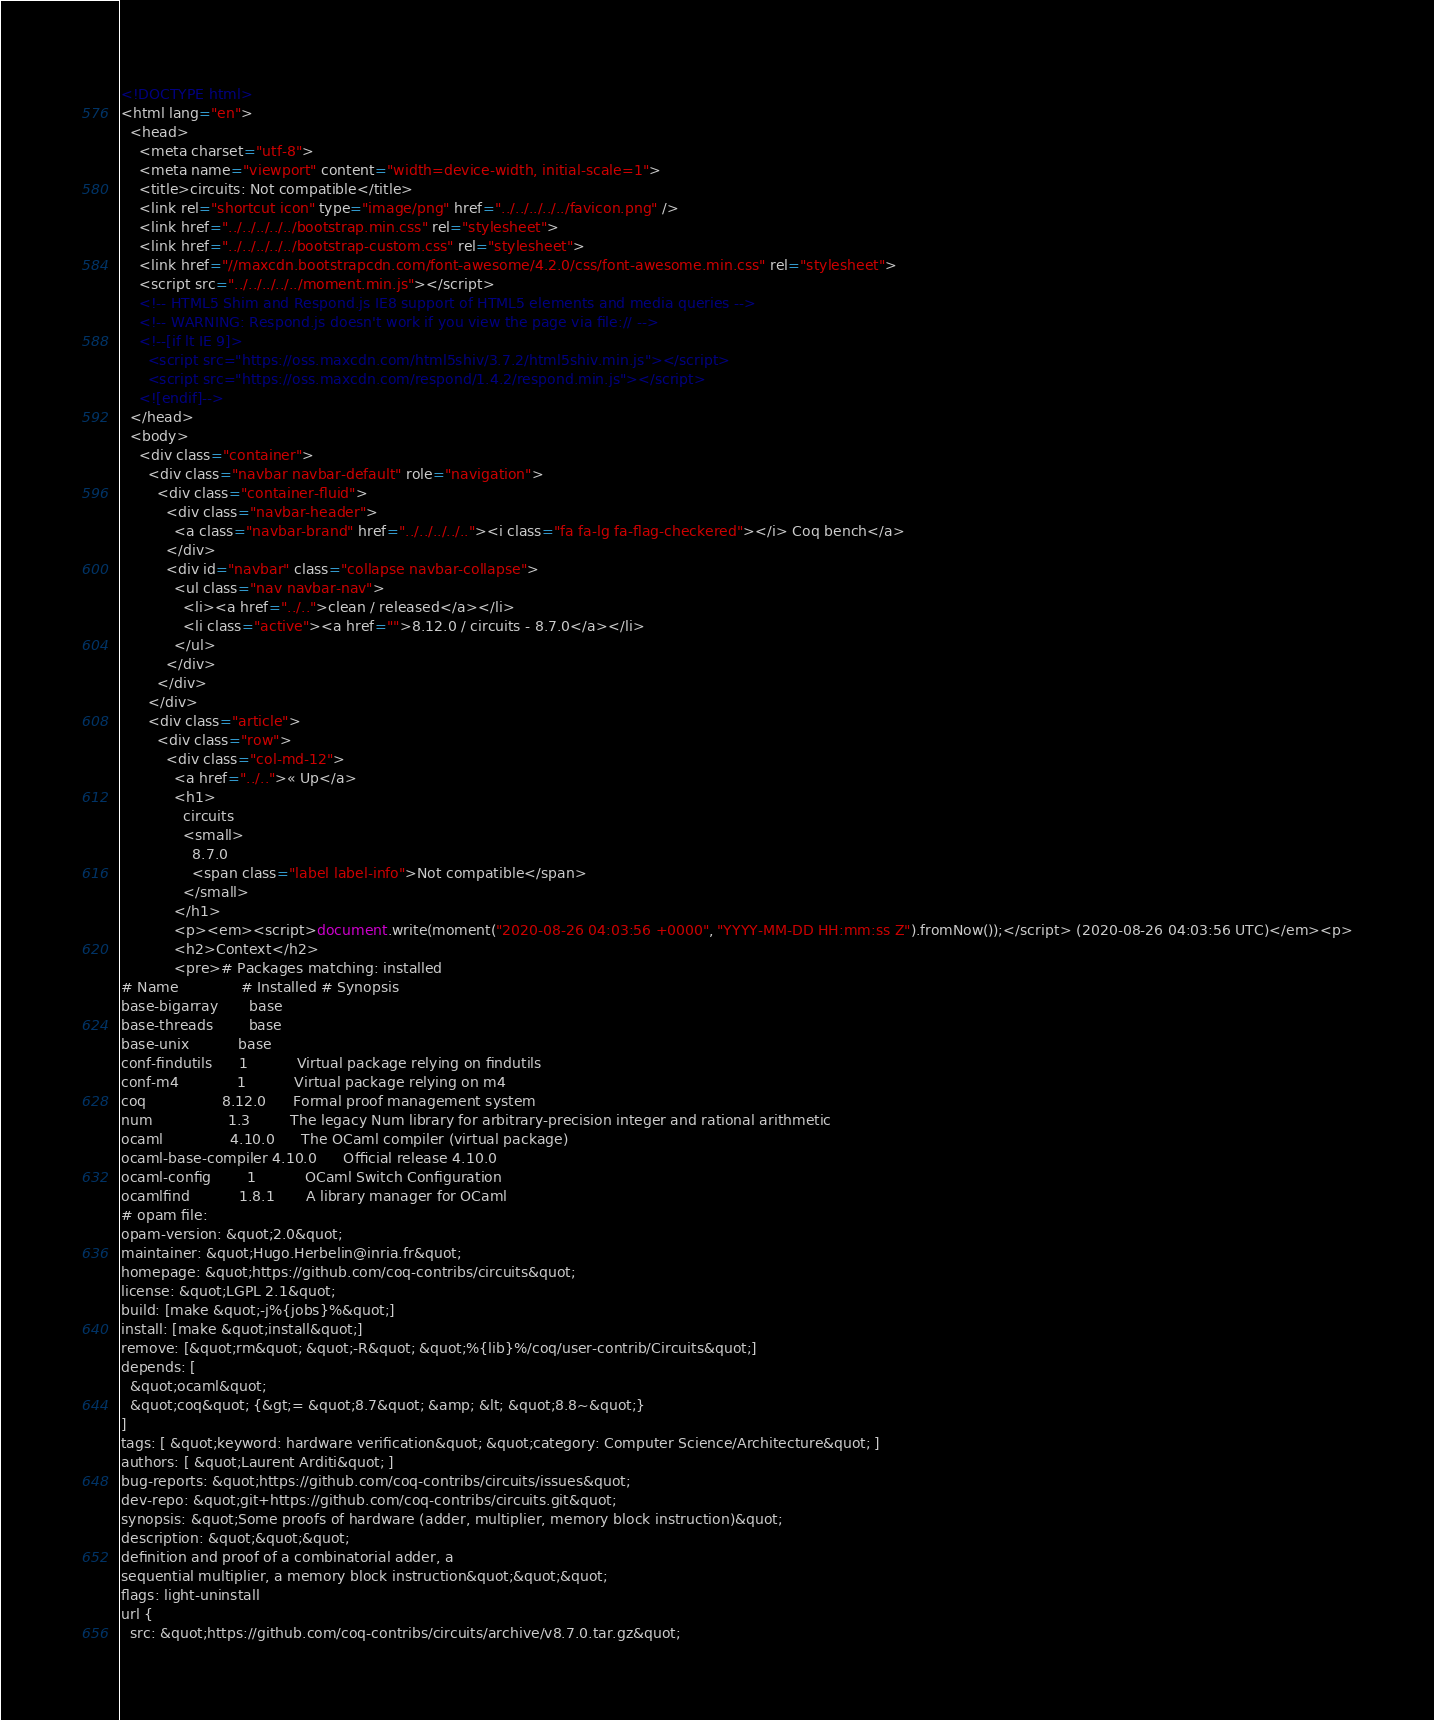Convert code to text. <code><loc_0><loc_0><loc_500><loc_500><_HTML_><!DOCTYPE html>
<html lang="en">
  <head>
    <meta charset="utf-8">
    <meta name="viewport" content="width=device-width, initial-scale=1">
    <title>circuits: Not compatible</title>
    <link rel="shortcut icon" type="image/png" href="../../../../../favicon.png" />
    <link href="../../../../../bootstrap.min.css" rel="stylesheet">
    <link href="../../../../../bootstrap-custom.css" rel="stylesheet">
    <link href="//maxcdn.bootstrapcdn.com/font-awesome/4.2.0/css/font-awesome.min.css" rel="stylesheet">
    <script src="../../../../../moment.min.js"></script>
    <!-- HTML5 Shim and Respond.js IE8 support of HTML5 elements and media queries -->
    <!-- WARNING: Respond.js doesn't work if you view the page via file:// -->
    <!--[if lt IE 9]>
      <script src="https://oss.maxcdn.com/html5shiv/3.7.2/html5shiv.min.js"></script>
      <script src="https://oss.maxcdn.com/respond/1.4.2/respond.min.js"></script>
    <![endif]-->
  </head>
  <body>
    <div class="container">
      <div class="navbar navbar-default" role="navigation">
        <div class="container-fluid">
          <div class="navbar-header">
            <a class="navbar-brand" href="../../../../.."><i class="fa fa-lg fa-flag-checkered"></i> Coq bench</a>
          </div>
          <div id="navbar" class="collapse navbar-collapse">
            <ul class="nav navbar-nav">
              <li><a href="../..">clean / released</a></li>
              <li class="active"><a href="">8.12.0 / circuits - 8.7.0</a></li>
            </ul>
          </div>
        </div>
      </div>
      <div class="article">
        <div class="row">
          <div class="col-md-12">
            <a href="../..">« Up</a>
            <h1>
              circuits
              <small>
                8.7.0
                <span class="label label-info">Not compatible</span>
              </small>
            </h1>
            <p><em><script>document.write(moment("2020-08-26 04:03:56 +0000", "YYYY-MM-DD HH:mm:ss Z").fromNow());</script> (2020-08-26 04:03:56 UTC)</em><p>
            <h2>Context</h2>
            <pre># Packages matching: installed
# Name              # Installed # Synopsis
base-bigarray       base
base-threads        base
base-unix           base
conf-findutils      1           Virtual package relying on findutils
conf-m4             1           Virtual package relying on m4
coq                 8.12.0      Formal proof management system
num                 1.3         The legacy Num library for arbitrary-precision integer and rational arithmetic
ocaml               4.10.0      The OCaml compiler (virtual package)
ocaml-base-compiler 4.10.0      Official release 4.10.0
ocaml-config        1           OCaml Switch Configuration
ocamlfind           1.8.1       A library manager for OCaml
# opam file:
opam-version: &quot;2.0&quot;
maintainer: &quot;Hugo.Herbelin@inria.fr&quot;
homepage: &quot;https://github.com/coq-contribs/circuits&quot;
license: &quot;LGPL 2.1&quot;
build: [make &quot;-j%{jobs}%&quot;]
install: [make &quot;install&quot;]
remove: [&quot;rm&quot; &quot;-R&quot; &quot;%{lib}%/coq/user-contrib/Circuits&quot;]
depends: [
  &quot;ocaml&quot;
  &quot;coq&quot; {&gt;= &quot;8.7&quot; &amp; &lt; &quot;8.8~&quot;}
]
tags: [ &quot;keyword: hardware verification&quot; &quot;category: Computer Science/Architecture&quot; ]
authors: [ &quot;Laurent Arditi&quot; ]
bug-reports: &quot;https://github.com/coq-contribs/circuits/issues&quot;
dev-repo: &quot;git+https://github.com/coq-contribs/circuits.git&quot;
synopsis: &quot;Some proofs of hardware (adder, multiplier, memory block instruction)&quot;
description: &quot;&quot;&quot;
definition and proof of a combinatorial adder, a
sequential multiplier, a memory block instruction&quot;&quot;&quot;
flags: light-uninstall
url {
  src: &quot;https://github.com/coq-contribs/circuits/archive/v8.7.0.tar.gz&quot;</code> 